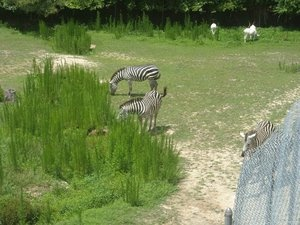Describe the objects in this image and their specific colors. I can see zebra in darkgreen, gray, and darkgray tones, zebra in darkgreen, gray, and darkgray tones, zebra in darkgreen, darkgray, gray, and beige tones, horse in darkgreen, ivory, gray, olive, and darkgray tones, and horse in darkgreen, ivory, and gray tones in this image. 